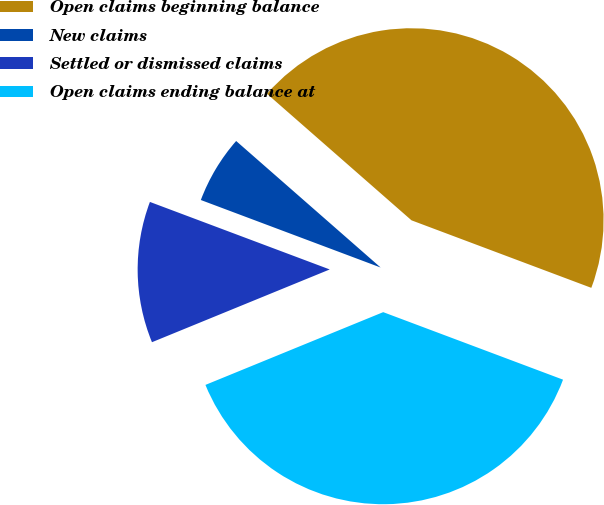Convert chart. <chart><loc_0><loc_0><loc_500><loc_500><pie_chart><fcel>Open claims beginning balance<fcel>New claims<fcel>Settled or dismissed claims<fcel>Open claims ending balance at<nl><fcel>44.27%<fcel>5.73%<fcel>11.9%<fcel>38.1%<nl></chart> 